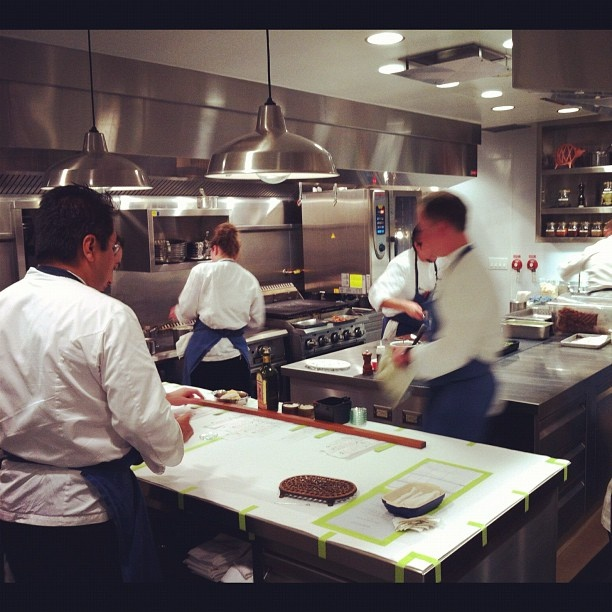Describe the objects in this image and their specific colors. I can see people in black, darkgray, lightgray, and gray tones, dining table in black, ivory, beige, and darkgray tones, people in black, darkgray, and gray tones, people in black, darkgray, and lightgray tones, and dining table in black, darkgray, and gray tones in this image. 